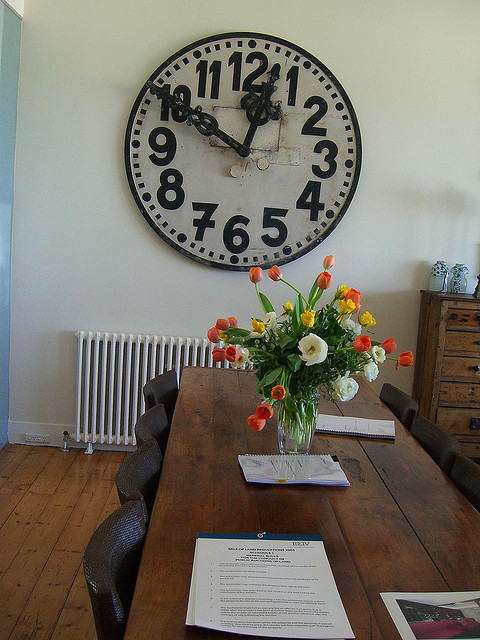<image>What type of martial is the clock on? I am not sure of the material of the clock. It might be on a wall, presumed to be drywall. What type of martial is the clock on? I don't know what type of martial is the clock on. It can be on a wall or a drywall. 